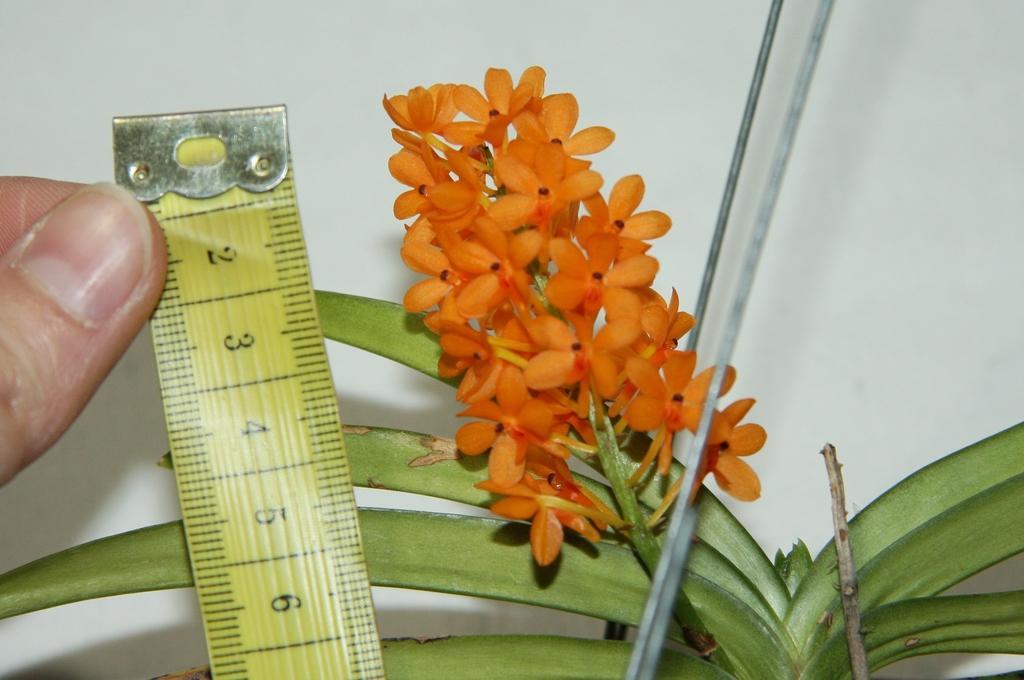In one or two sentences, can you explain what this image depicts? In this picture there is a person holding the tape. There are orange color flowers on the plant. At the back there is a wall. 